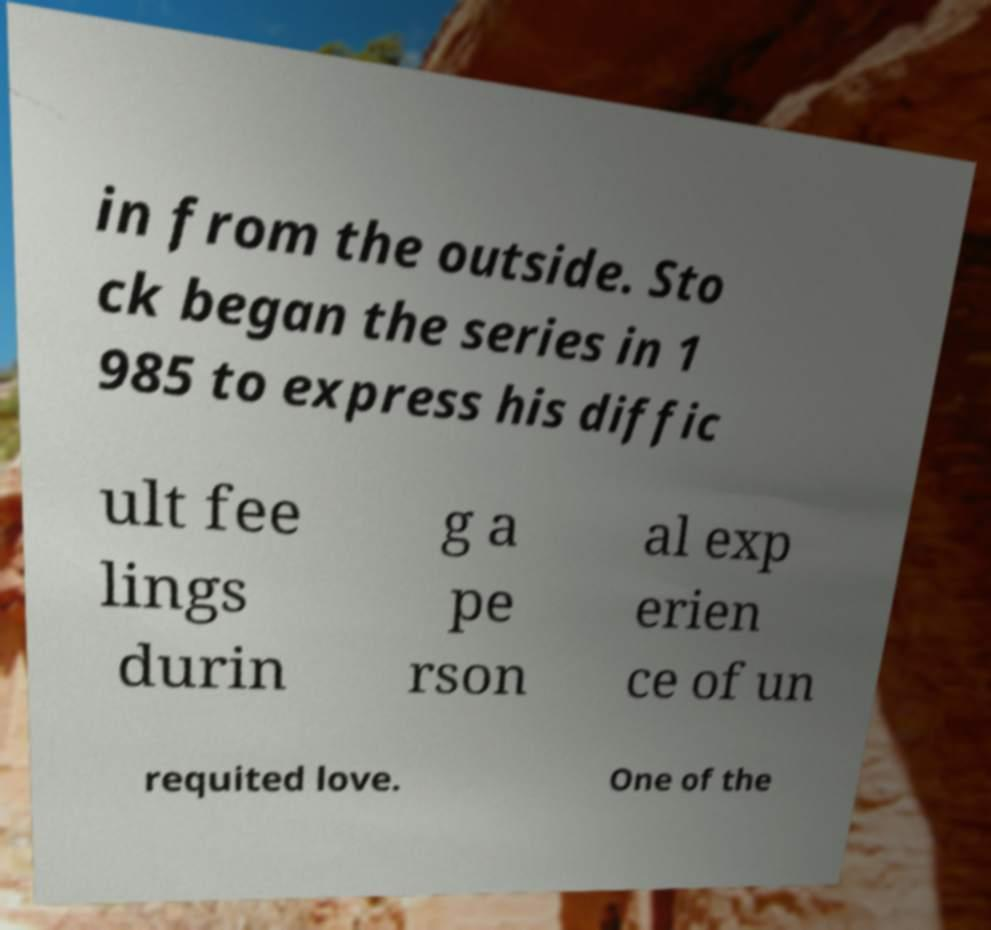I need the written content from this picture converted into text. Can you do that? in from the outside. Sto ck began the series in 1 985 to express his diffic ult fee lings durin g a pe rson al exp erien ce of un requited love. One of the 